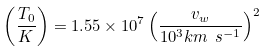Convert formula to latex. <formula><loc_0><loc_0><loc_500><loc_500>\left ( \frac { T _ { 0 } } { K } \right ) = 1 . 5 5 \times 1 0 ^ { 7 } \left ( \frac { v _ { w } } { 1 0 ^ { 3 } k m \ s ^ { - 1 } } \right ) ^ { 2 }</formula> 